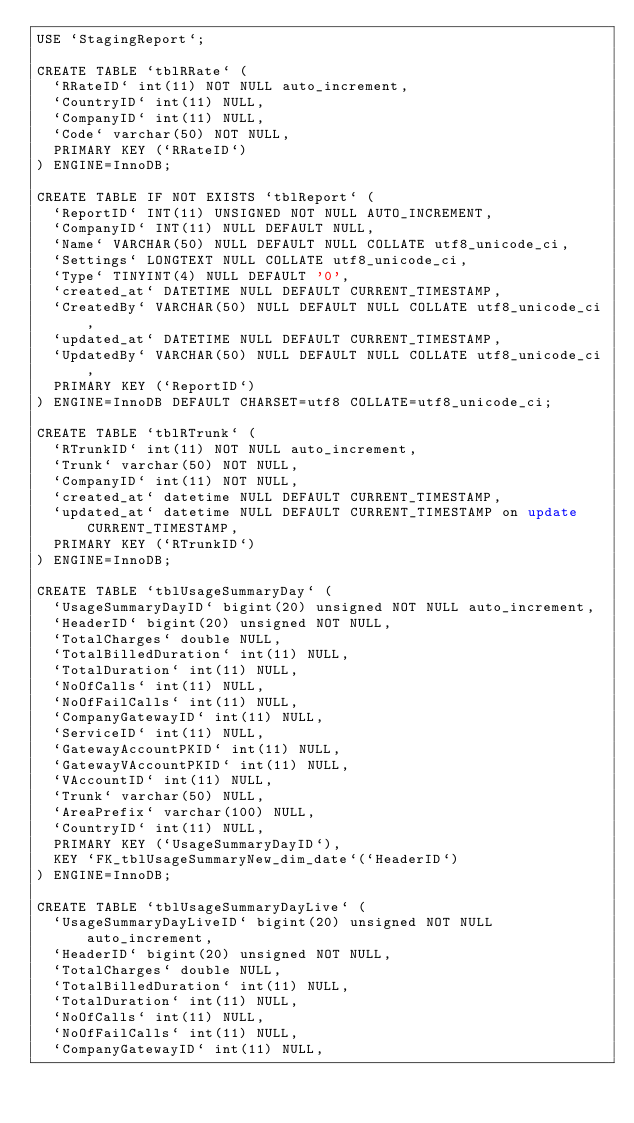Convert code to text. <code><loc_0><loc_0><loc_500><loc_500><_SQL_>USE `StagingReport`;

CREATE TABLE `tblRRate` (
  `RRateID` int(11) NOT NULL auto_increment,
  `CountryID` int(11) NULL,
  `CompanyID` int(11) NULL,
  `Code` varchar(50) NOT NULL,
  PRIMARY KEY (`RRateID`)
) ENGINE=InnoDB;

CREATE TABLE IF NOT EXISTS `tblReport` (
  `ReportID` INT(11) UNSIGNED NOT NULL AUTO_INCREMENT,
  `CompanyID` INT(11) NULL DEFAULT NULL,
  `Name` VARCHAR(50) NULL DEFAULT NULL COLLATE utf8_unicode_ci,
  `Settings` LONGTEXT NULL COLLATE utf8_unicode_ci,
  `Type` TINYINT(4) NULL DEFAULT '0',
  `created_at` DATETIME NULL DEFAULT CURRENT_TIMESTAMP,
  `CreatedBy` VARCHAR(50) NULL DEFAULT NULL COLLATE utf8_unicode_ci,
  `updated_at` DATETIME NULL DEFAULT CURRENT_TIMESTAMP,
  `UpdatedBy` VARCHAR(50) NULL DEFAULT NULL COLLATE utf8_unicode_ci,
  PRIMARY KEY (`ReportID`)
) ENGINE=InnoDB DEFAULT CHARSET=utf8 COLLATE=utf8_unicode_ci;

CREATE TABLE `tblRTrunk` (
  `RTrunkID` int(11) NOT NULL auto_increment,
  `Trunk` varchar(50) NOT NULL,
  `CompanyID` int(11) NOT NULL,
  `created_at` datetime NULL DEFAULT CURRENT_TIMESTAMP,
  `updated_at` datetime NULL DEFAULT CURRENT_TIMESTAMP on update CURRENT_TIMESTAMP,
  PRIMARY KEY (`RTrunkID`)
) ENGINE=InnoDB;

CREATE TABLE `tblUsageSummaryDay` (
  `UsageSummaryDayID` bigint(20) unsigned NOT NULL auto_increment,
  `HeaderID` bigint(20) unsigned NOT NULL,
  `TotalCharges` double NULL,
  `TotalBilledDuration` int(11) NULL,
  `TotalDuration` int(11) NULL,
  `NoOfCalls` int(11) NULL,
  `NoOfFailCalls` int(11) NULL,
  `CompanyGatewayID` int(11) NULL,
  `ServiceID` int(11) NULL,
  `GatewayAccountPKID` int(11) NULL,
  `GatewayVAccountPKID` int(11) NULL,
  `VAccountID` int(11) NULL,
  `Trunk` varchar(50) NULL,
  `AreaPrefix` varchar(100) NULL,
  `CountryID` int(11) NULL,
  PRIMARY KEY (`UsageSummaryDayID`),
  KEY `FK_tblUsageSummaryNew_dim_date`(`HeaderID`)
) ENGINE=InnoDB;

CREATE TABLE `tblUsageSummaryDayLive` (
  `UsageSummaryDayLiveID` bigint(20) unsigned NOT NULL auto_increment,
  `HeaderID` bigint(20) unsigned NOT NULL,
  `TotalCharges` double NULL,
  `TotalBilledDuration` int(11) NULL,
  `TotalDuration` int(11) NULL,
  `NoOfCalls` int(11) NULL,
  `NoOfFailCalls` int(11) NULL,
  `CompanyGatewayID` int(11) NULL,</code> 